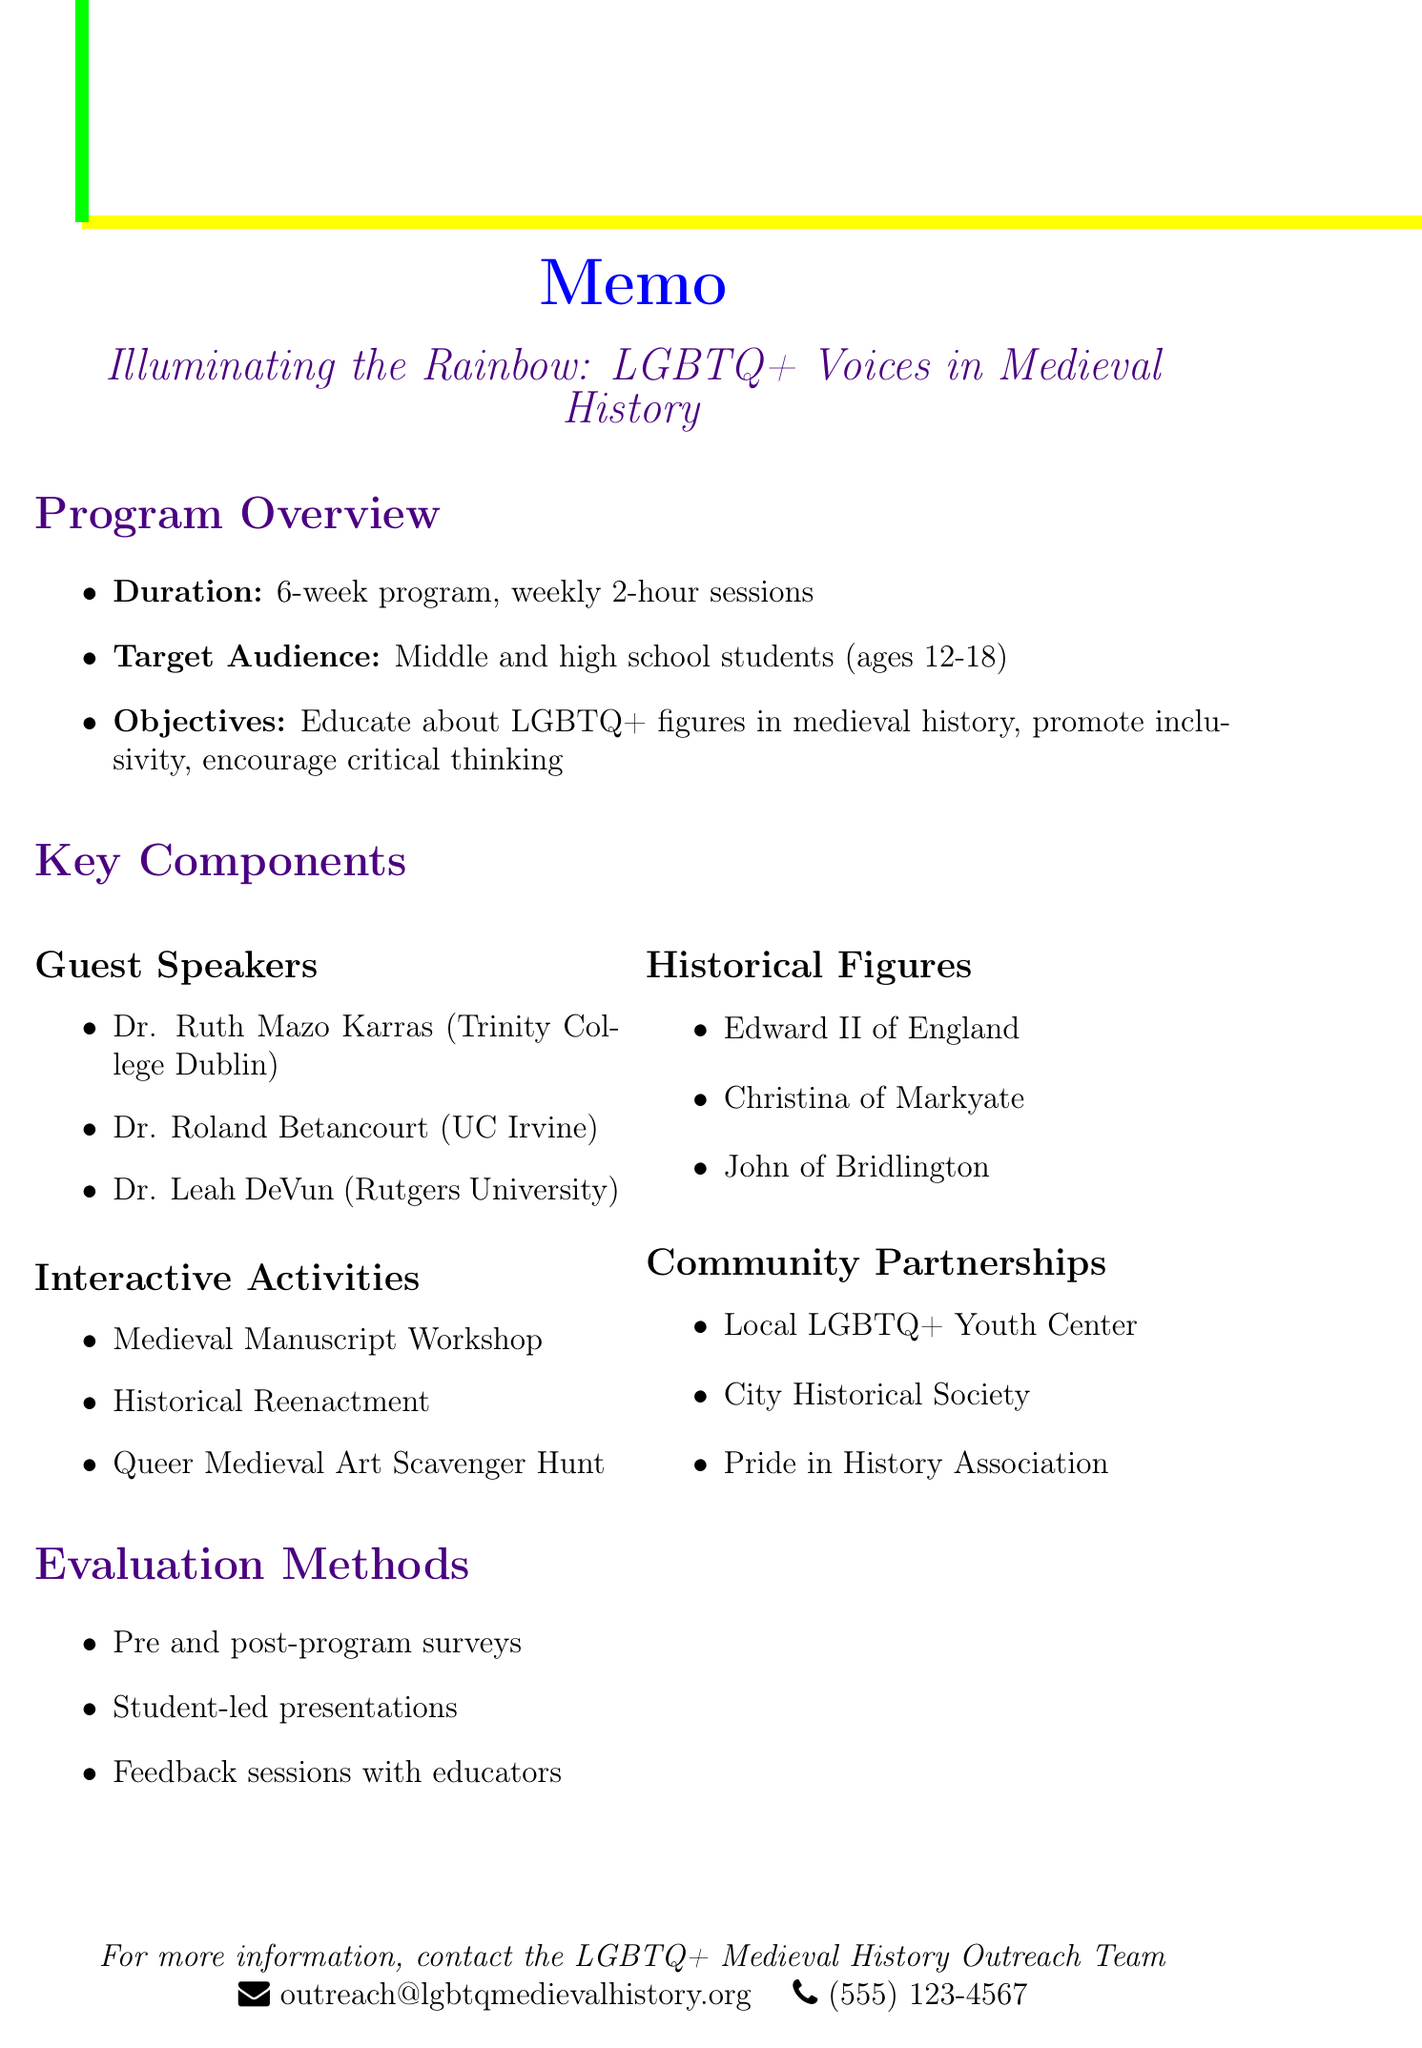what is the title of the program? The title of the program is stated at the beginning of the document.
Answer: Illuminating the Rainbow: LGBTQ+ Voices in Medieval History how long is the program's duration? The duration of the program is specified in the overview section of the document.
Answer: 6-week program who is one of the proposed guest speakers? The document lists several guest speakers in the key components section.
Answer: Dr. Ruth Mazo Karras what is one interactive activity mentioned in the document? The document includes a list of interactive activities under the key components section.
Answer: Medieval Manuscript Workshop which historical figure is associated with same-sex desire in hagiography? The document provides names and significance of key historical figures in medieval history.
Answer: John of Bridlington what type of evaluation method involves surveys? The evaluation methods listed in the document state various ways to measure the program's effectiveness.
Answer: Pre and post-program surveys which community partnership offers a venue for events? The document outlines various community partnerships and their roles.
Answer: City Historical Society what age group is the target audience for this program? Information about the target audience is provided in the program overview section.
Answer: 12-18 